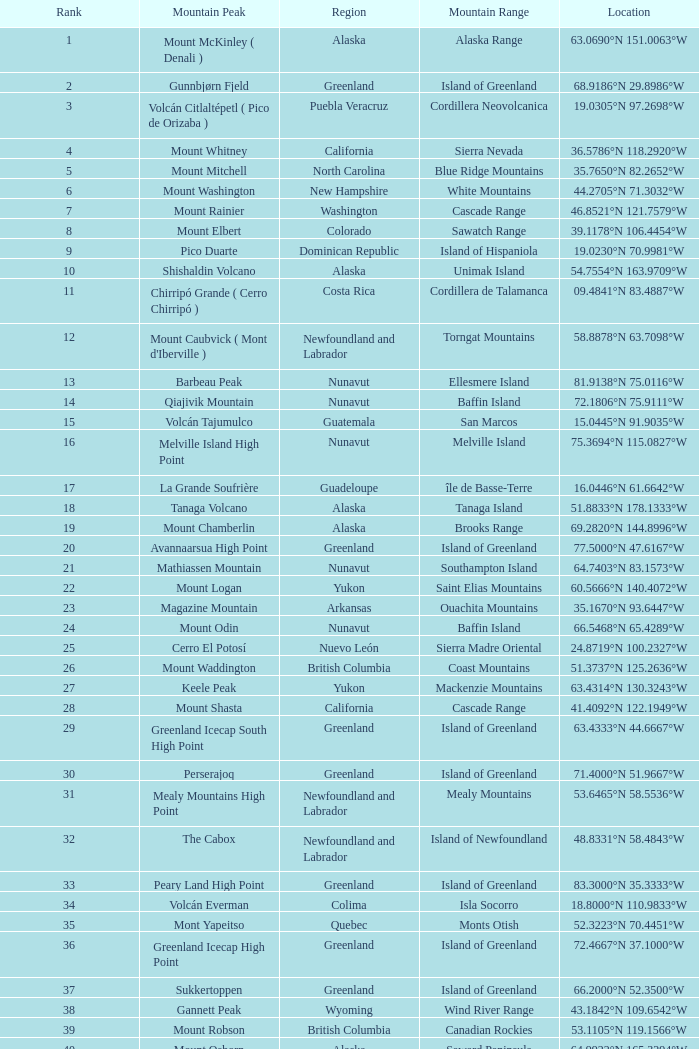Which Mountain Peak has a Region of baja california, and a Location of 28.1301°n 115.2206°w? Isla Cedros High Point. 